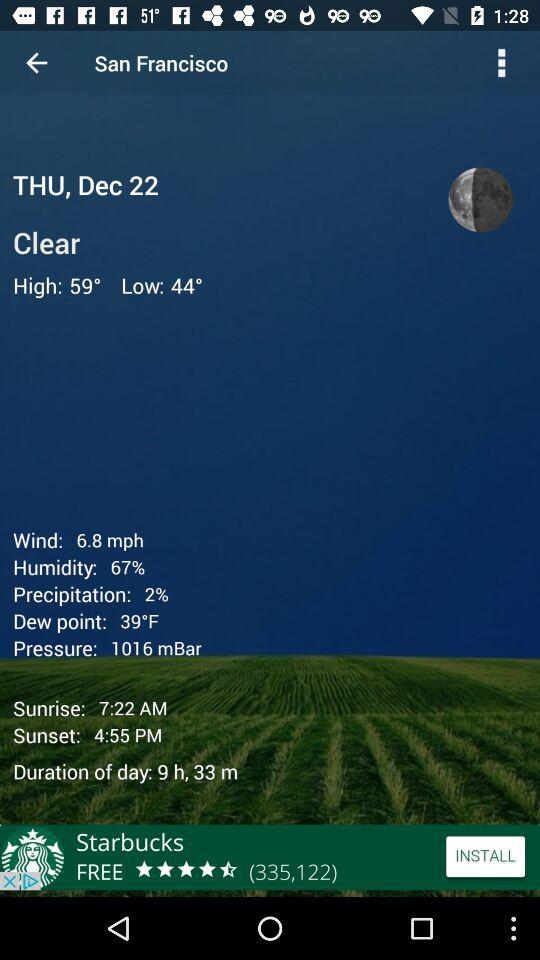What is the difference in temperature between the high and low temperatures?
Answer the question using a single word or phrase. 15° 